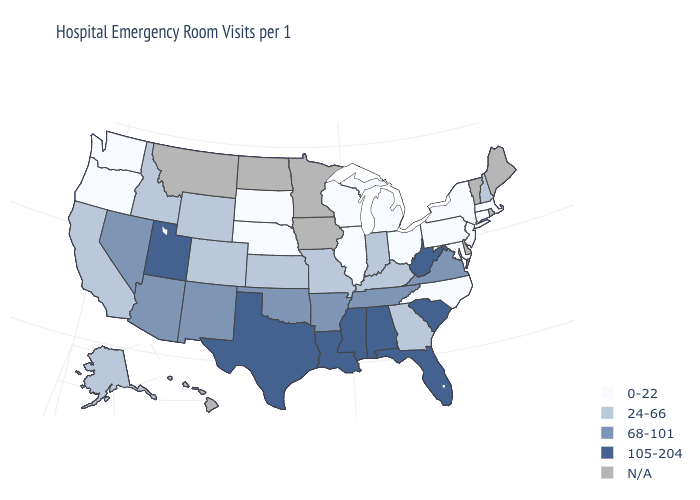Which states hav the highest value in the South?
Quick response, please. Alabama, Florida, Louisiana, Mississippi, South Carolina, Texas, West Virginia. What is the value of Colorado?
Answer briefly. 24-66. Among the states that border Utah , which have the highest value?
Answer briefly. Arizona, Nevada, New Mexico. Name the states that have a value in the range 68-101?
Keep it brief. Arizona, Arkansas, Nevada, New Mexico, Oklahoma, Tennessee, Virginia. What is the value of Pennsylvania?
Quick response, please. 0-22. What is the highest value in the USA?
Quick response, please. 105-204. What is the highest value in states that border Pennsylvania?
Short answer required. 105-204. Is the legend a continuous bar?
Write a very short answer. No. What is the value of Maryland?
Be succinct. 0-22. Among the states that border Idaho , which have the highest value?
Short answer required. Utah. What is the highest value in the USA?
Answer briefly. 105-204. Which states have the highest value in the USA?
Be succinct. Alabama, Florida, Louisiana, Mississippi, South Carolina, Texas, Utah, West Virginia. Does the map have missing data?
Short answer required. Yes. Is the legend a continuous bar?
Give a very brief answer. No. 